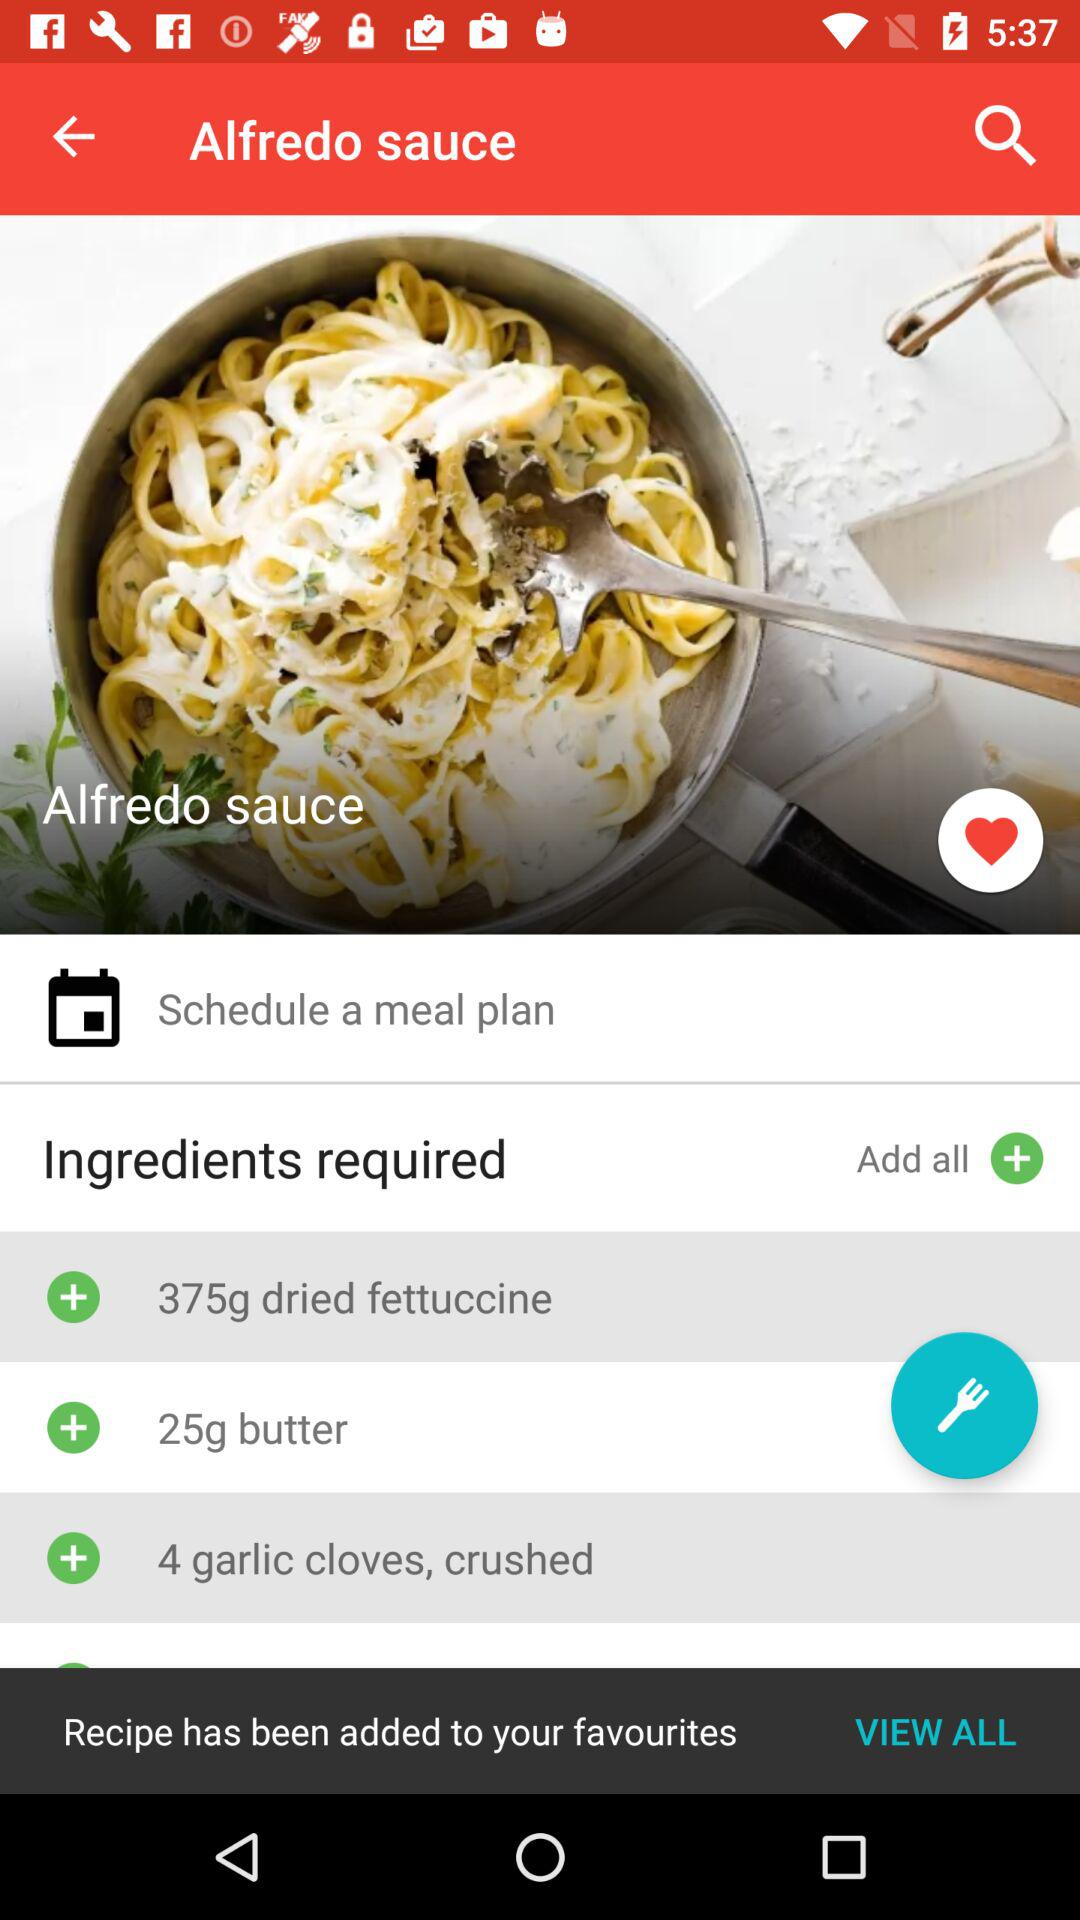How much cream is required for the recipe?
When the provided information is insufficient, respond with <no answer>. <no answer> 